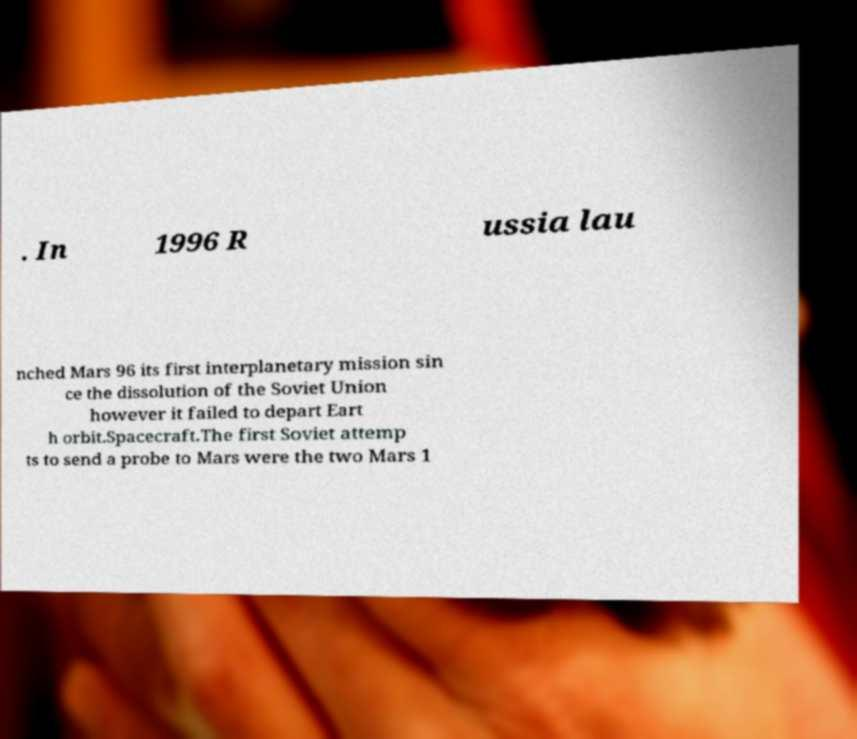I need the written content from this picture converted into text. Can you do that? . In 1996 R ussia lau nched Mars 96 its first interplanetary mission sin ce the dissolution of the Soviet Union however it failed to depart Eart h orbit.Spacecraft.The first Soviet attemp ts to send a probe to Mars were the two Mars 1 